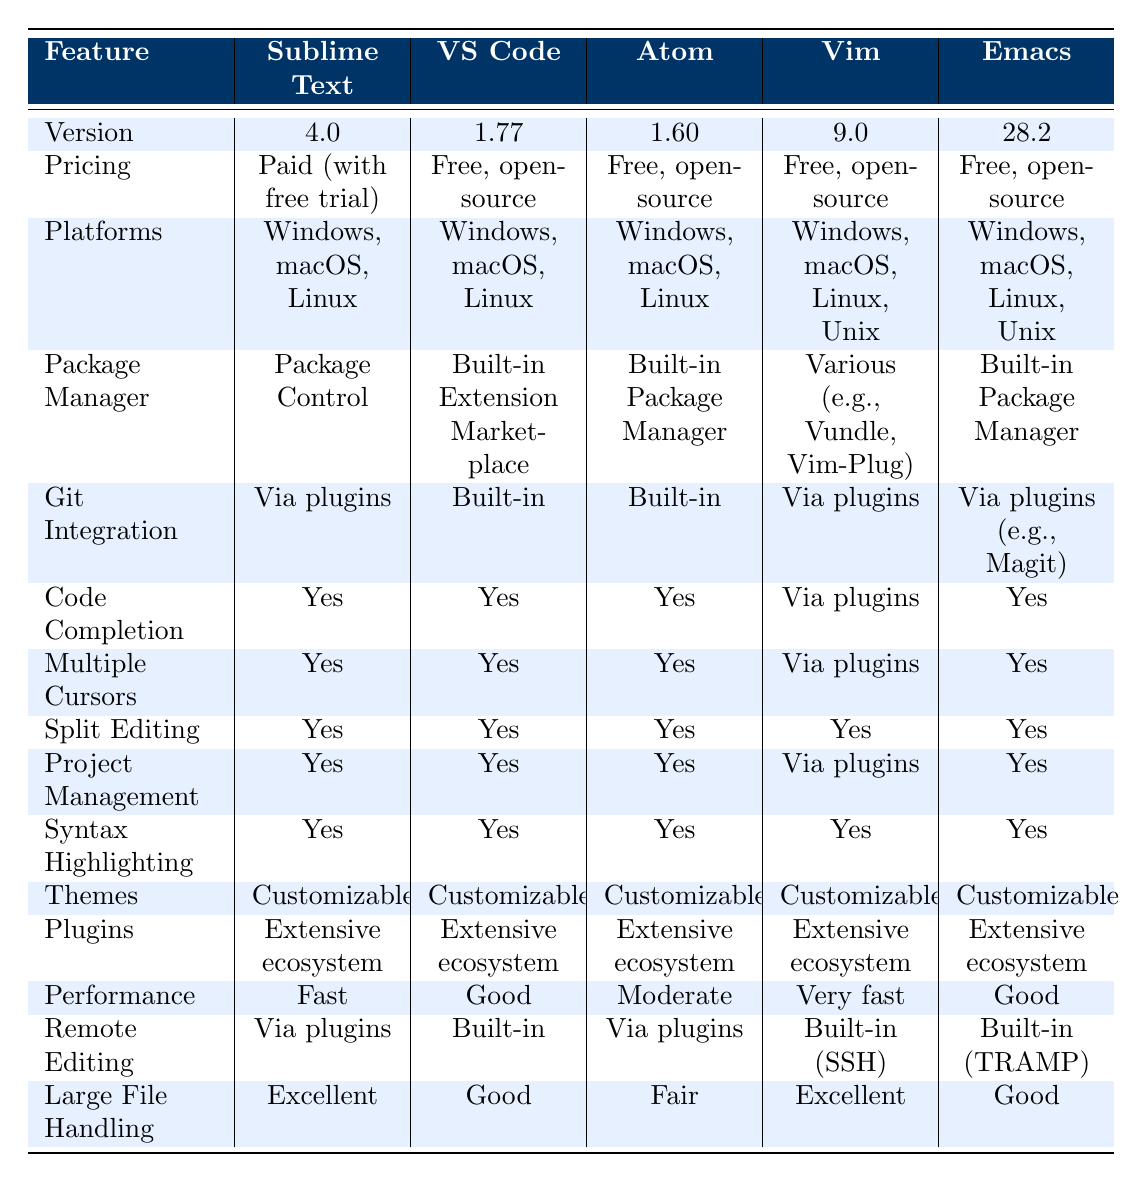What is the version of Sublime Text? The table displays the version for each text editor in the second row. For Sublime Text, the corresponding value is 4.0.
Answer: 4.0 Which text editors have built-in Git integration? In the Git Integration row, we can see that Visual Studio Code and Atom both have "Built-in" listed. This indicates those two editors have built-in Git integration.
Answer: Visual Studio Code, Atom What is the performance rating of Atom compared to Sublime Text? In the Performance row, Atom is rated as "Moderate" and Sublime Text is rated as "Fast." This means that Sublime Text is rated higher in performance than Atom.
Answer: Sublime Text has higher performance Does both Vim and Emacs have customizable themes? By checking the Themes row, we find that both Vim and Emacs are marked as "Customizable," indicating that they both indeed offer customizable themes.
Answer: Yes Which text editor has the best large file handling? In the Large File Handling row, both Sublime Text and Vim have "Excellent" listed, which makes them the best in this category for large file handling.
Answer: Sublime Text, Vim How many text editors support split editing? In the Split Editing row, we see that all text editors mentioned have "Yes" listed. This means all five text editors support this feature.
Answer: Five text editors Which editors are available on Unix platforms? Looking at the Platforms row, Vim and Emacs are the only editors that list Unix as a supported platform alongside Windows, macOS, and Linux.
Answer: Vim, Emacs Is the package manager for Visual Studio Code the same as that of Sublime Text? Upon reviewing the Package Manager column, we see that Visual Studio Code has a "Built-in Extension Marketplace," while Sublime Text uses "Package Control," indicating they are different.
Answer: No What is the average performance rating of the text editors listed? The performance ratings can be numerically assigned: Fast (3), Good (2), Moderate (1), Very fast (4). Thus, the average is calculated as (3 + 2 + 1 + 4 + 2) / 5 = 2.4, which corresponds to a performance rating between Good and Moderate.
Answer: 2.4 